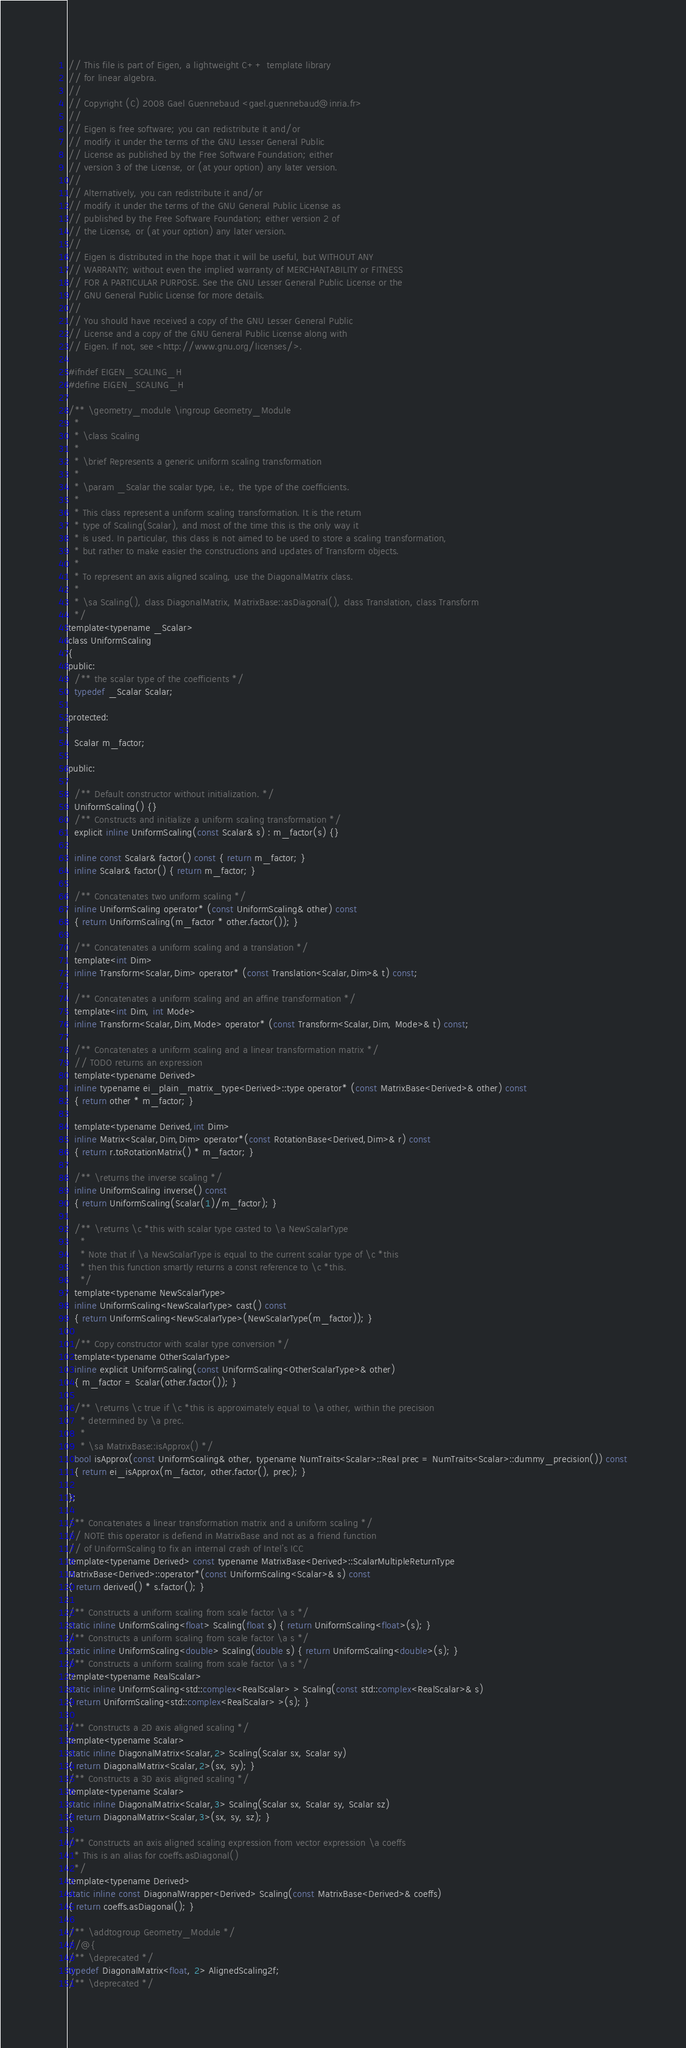Convert code to text. <code><loc_0><loc_0><loc_500><loc_500><_C_>// This file is part of Eigen, a lightweight C++ template library
// for linear algebra.
//
// Copyright (C) 2008 Gael Guennebaud <gael.guennebaud@inria.fr>
//
// Eigen is free software; you can redistribute it and/or
// modify it under the terms of the GNU Lesser General Public
// License as published by the Free Software Foundation; either
// version 3 of the License, or (at your option) any later version.
//
// Alternatively, you can redistribute it and/or
// modify it under the terms of the GNU General Public License as
// published by the Free Software Foundation; either version 2 of
// the License, or (at your option) any later version.
//
// Eigen is distributed in the hope that it will be useful, but WITHOUT ANY
// WARRANTY; without even the implied warranty of MERCHANTABILITY or FITNESS
// FOR A PARTICULAR PURPOSE. See the GNU Lesser General Public License or the
// GNU General Public License for more details.
//
// You should have received a copy of the GNU Lesser General Public
// License and a copy of the GNU General Public License along with
// Eigen. If not, see <http://www.gnu.org/licenses/>.

#ifndef EIGEN_SCALING_H
#define EIGEN_SCALING_H

/** \geometry_module \ingroup Geometry_Module
  *
  * \class Scaling
  *
  * \brief Represents a generic uniform scaling transformation
  *
  * \param _Scalar the scalar type, i.e., the type of the coefficients.
  *
  * This class represent a uniform scaling transformation. It is the return
  * type of Scaling(Scalar), and most of the time this is the only way it
  * is used. In particular, this class is not aimed to be used to store a scaling transformation,
  * but rather to make easier the constructions and updates of Transform objects.
  *
  * To represent an axis aligned scaling, use the DiagonalMatrix class.
  *
  * \sa Scaling(), class DiagonalMatrix, MatrixBase::asDiagonal(), class Translation, class Transform
  */
template<typename _Scalar>
class UniformScaling
{
public:
  /** the scalar type of the coefficients */
  typedef _Scalar Scalar;

protected:

  Scalar m_factor;

public:

  /** Default constructor without initialization. */
  UniformScaling() {}
  /** Constructs and initialize a uniform scaling transformation */
  explicit inline UniformScaling(const Scalar& s) : m_factor(s) {}

  inline const Scalar& factor() const { return m_factor; }
  inline Scalar& factor() { return m_factor; }

  /** Concatenates two uniform scaling */
  inline UniformScaling operator* (const UniformScaling& other) const
  { return UniformScaling(m_factor * other.factor()); }

  /** Concatenates a uniform scaling and a translation */
  template<int Dim>
  inline Transform<Scalar,Dim> operator* (const Translation<Scalar,Dim>& t) const;

  /** Concatenates a uniform scaling and an affine transformation */
  template<int Dim, int Mode>
  inline Transform<Scalar,Dim,Mode> operator* (const Transform<Scalar,Dim, Mode>& t) const;

  /** Concatenates a uniform scaling and a linear transformation matrix */
  // TODO returns an expression
  template<typename Derived>
  inline typename ei_plain_matrix_type<Derived>::type operator* (const MatrixBase<Derived>& other) const
  { return other * m_factor; }

  template<typename Derived,int Dim>
  inline Matrix<Scalar,Dim,Dim> operator*(const RotationBase<Derived,Dim>& r) const
  { return r.toRotationMatrix() * m_factor; }

  /** \returns the inverse scaling */
  inline UniformScaling inverse() const
  { return UniformScaling(Scalar(1)/m_factor); }

  /** \returns \c *this with scalar type casted to \a NewScalarType
    *
    * Note that if \a NewScalarType is equal to the current scalar type of \c *this
    * then this function smartly returns a const reference to \c *this.
    */
  template<typename NewScalarType>
  inline UniformScaling<NewScalarType> cast() const
  { return UniformScaling<NewScalarType>(NewScalarType(m_factor)); }

  /** Copy constructor with scalar type conversion */
  template<typename OtherScalarType>
  inline explicit UniformScaling(const UniformScaling<OtherScalarType>& other)
  { m_factor = Scalar(other.factor()); }

  /** \returns \c true if \c *this is approximately equal to \a other, within the precision
    * determined by \a prec.
    *
    * \sa MatrixBase::isApprox() */
  bool isApprox(const UniformScaling& other, typename NumTraits<Scalar>::Real prec = NumTraits<Scalar>::dummy_precision()) const
  { return ei_isApprox(m_factor, other.factor(), prec); }

};

/** Concatenates a linear transformation matrix and a uniform scaling */
// NOTE this operator is defiend in MatrixBase and not as a friend function
// of UniformScaling to fix an internal crash of Intel's ICC
template<typename Derived> const typename MatrixBase<Derived>::ScalarMultipleReturnType
MatrixBase<Derived>::operator*(const UniformScaling<Scalar>& s) const
{ return derived() * s.factor(); }

/** Constructs a uniform scaling from scale factor \a s */
static inline UniformScaling<float> Scaling(float s) { return UniformScaling<float>(s); }
/** Constructs a uniform scaling from scale factor \a s */
static inline UniformScaling<double> Scaling(double s) { return UniformScaling<double>(s); }
/** Constructs a uniform scaling from scale factor \a s */
template<typename RealScalar>
static inline UniformScaling<std::complex<RealScalar> > Scaling(const std::complex<RealScalar>& s)
{ return UniformScaling<std::complex<RealScalar> >(s); }

/** Constructs a 2D axis aligned scaling */
template<typename Scalar>
static inline DiagonalMatrix<Scalar,2> Scaling(Scalar sx, Scalar sy)
{ return DiagonalMatrix<Scalar,2>(sx, sy); }
/** Constructs a 3D axis aligned scaling */
template<typename Scalar>
static inline DiagonalMatrix<Scalar,3> Scaling(Scalar sx, Scalar sy, Scalar sz)
{ return DiagonalMatrix<Scalar,3>(sx, sy, sz); }

/** Constructs an axis aligned scaling expression from vector expression \a coeffs
  * This is an alias for coeffs.asDiagonal()
  */
template<typename Derived>
static inline const DiagonalWrapper<Derived> Scaling(const MatrixBase<Derived>& coeffs)
{ return coeffs.asDiagonal(); }

/** \addtogroup Geometry_Module */
//@{
/** \deprecated */
typedef DiagonalMatrix<float, 2> AlignedScaling2f;
/** \deprecated */</code> 